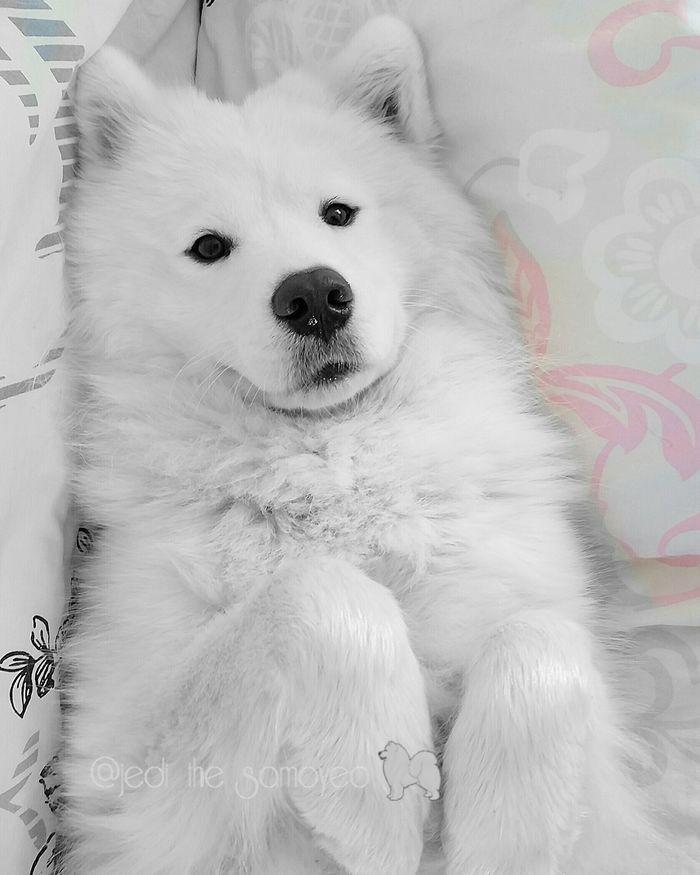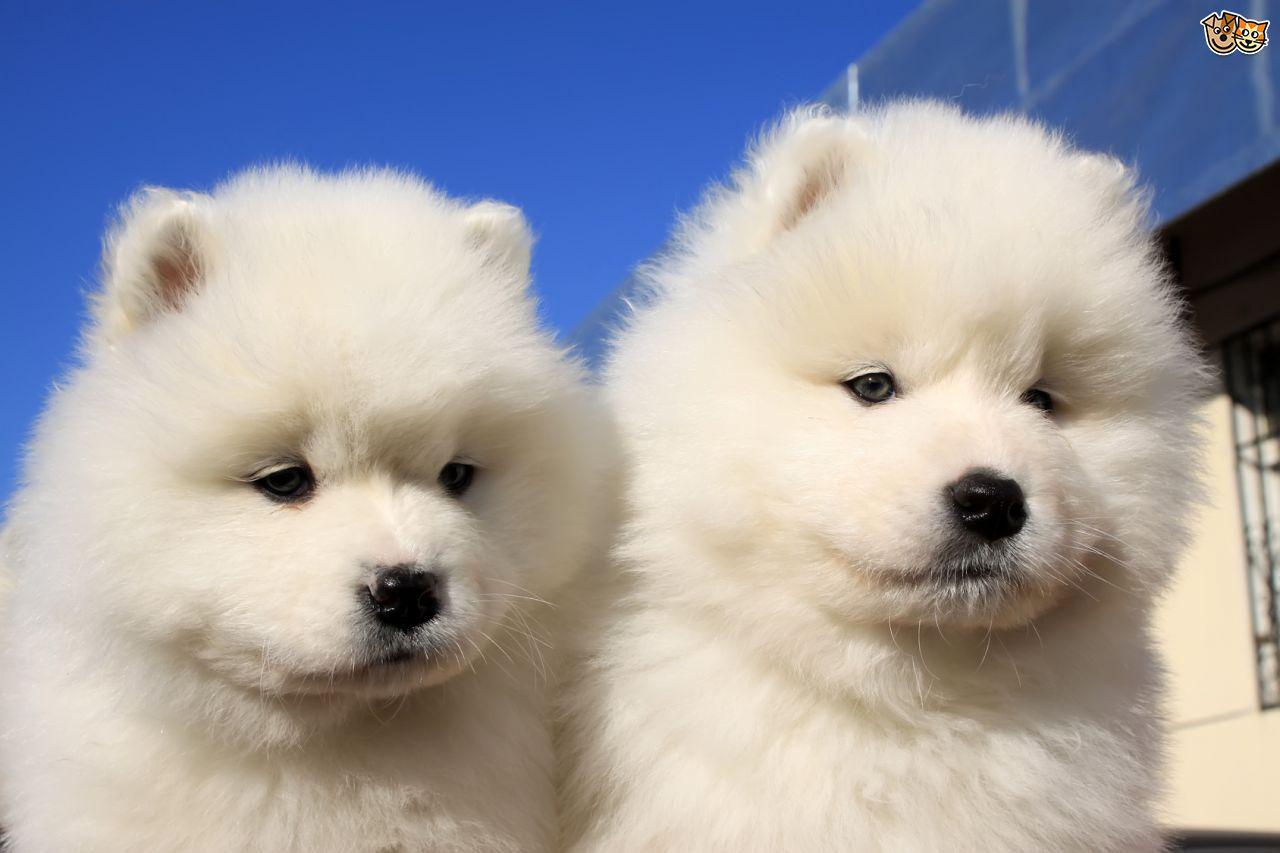The first image is the image on the left, the second image is the image on the right. For the images displayed, is the sentence "A white dog is outside in the snow." factually correct? Answer yes or no. No. The first image is the image on the left, the second image is the image on the right. For the images displayed, is the sentence "There are at least two dogs in the image on the right." factually correct? Answer yes or no. Yes. 